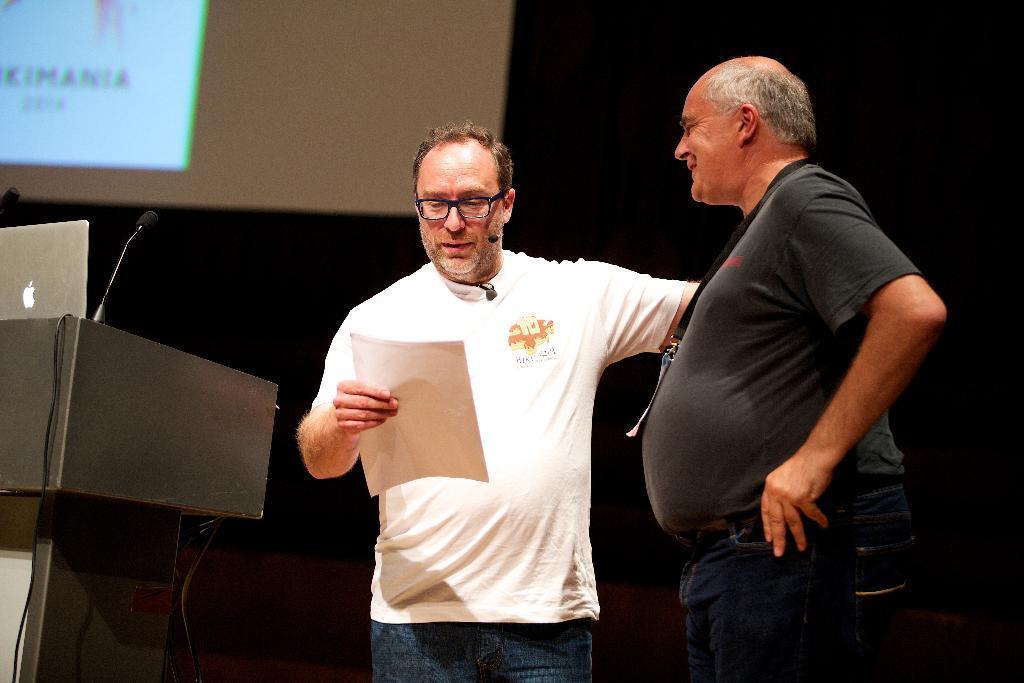Can you describe this image briefly? In the center of the image there are two persons standing. In the background of the image there is a screen. To the left side of the image there is a podium, there is a laptop on it. 